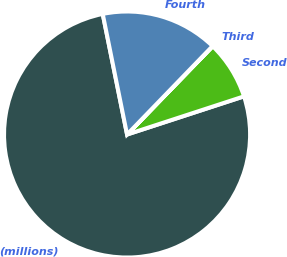<chart> <loc_0><loc_0><loc_500><loc_500><pie_chart><fcel>(millions)<fcel>Second<fcel>Third<fcel>Fourth<nl><fcel>76.85%<fcel>7.72%<fcel>0.03%<fcel>15.4%<nl></chart> 